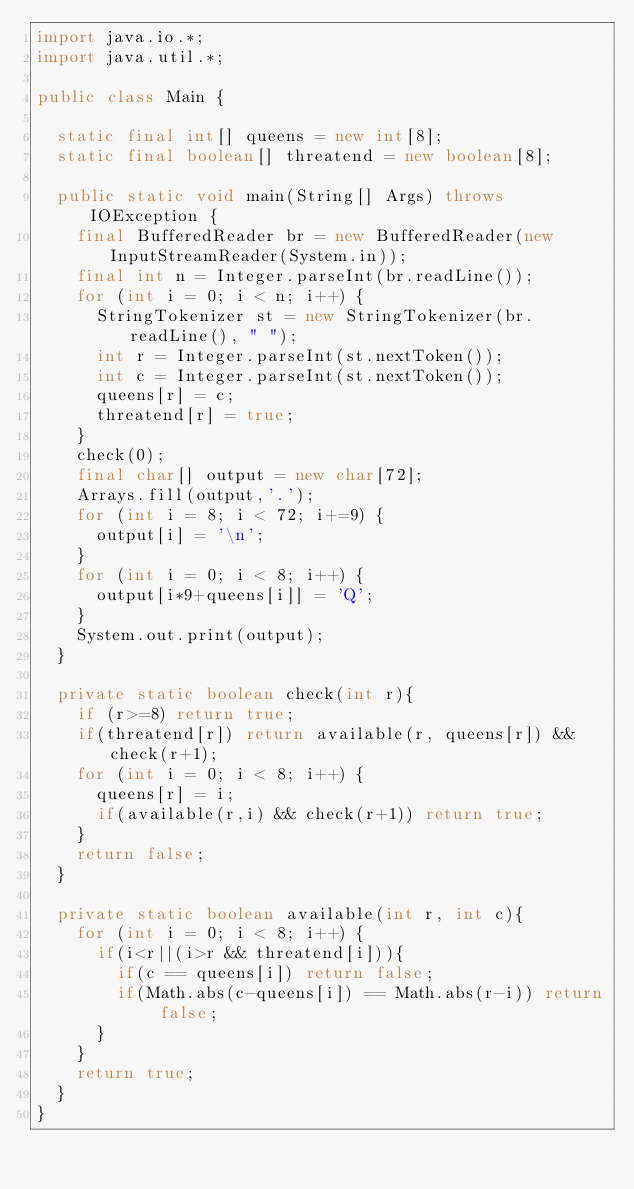<code> <loc_0><loc_0><loc_500><loc_500><_Java_>import java.io.*;
import java.util.*;

public class Main {
	
	static final int[] queens = new int[8];
	static final boolean[] threatend = new boolean[8];
	
	public static void main(String[] Args) throws IOException {
		final BufferedReader br = new BufferedReader(new InputStreamReader(System.in));
		final int n = Integer.parseInt(br.readLine());
		for (int i = 0; i < n; i++) {
			StringTokenizer st = new StringTokenizer(br.readLine(), " ");
			int r = Integer.parseInt(st.nextToken());
			int c = Integer.parseInt(st.nextToken());
			queens[r] = c;
			threatend[r] = true;
		}
		check(0);
		final char[] output = new char[72];
		Arrays.fill(output,'.');
		for (int i = 8; i < 72; i+=9) {
			output[i] = '\n';
		}
		for (int i = 0; i < 8; i++) {
			output[i*9+queens[i]] = 'Q';
		}
		System.out.print(output);
	}
	
	private static boolean check(int r){
		if (r>=8) return true;
		if(threatend[r]) return available(r, queens[r]) && check(r+1);
		for (int i = 0; i < 8; i++) {
			queens[r] = i;
			if(available(r,i) && check(r+1)) return true;
		}
		return false;
	}
	
	private static boolean available(int r, int c){
		for (int i = 0; i < 8; i++) {
			if(i<r||(i>r && threatend[i])){
				if(c == queens[i]) return false;
				if(Math.abs(c-queens[i]) == Math.abs(r-i)) return false;
			}
		}
		return true;
	}
}
</code> 